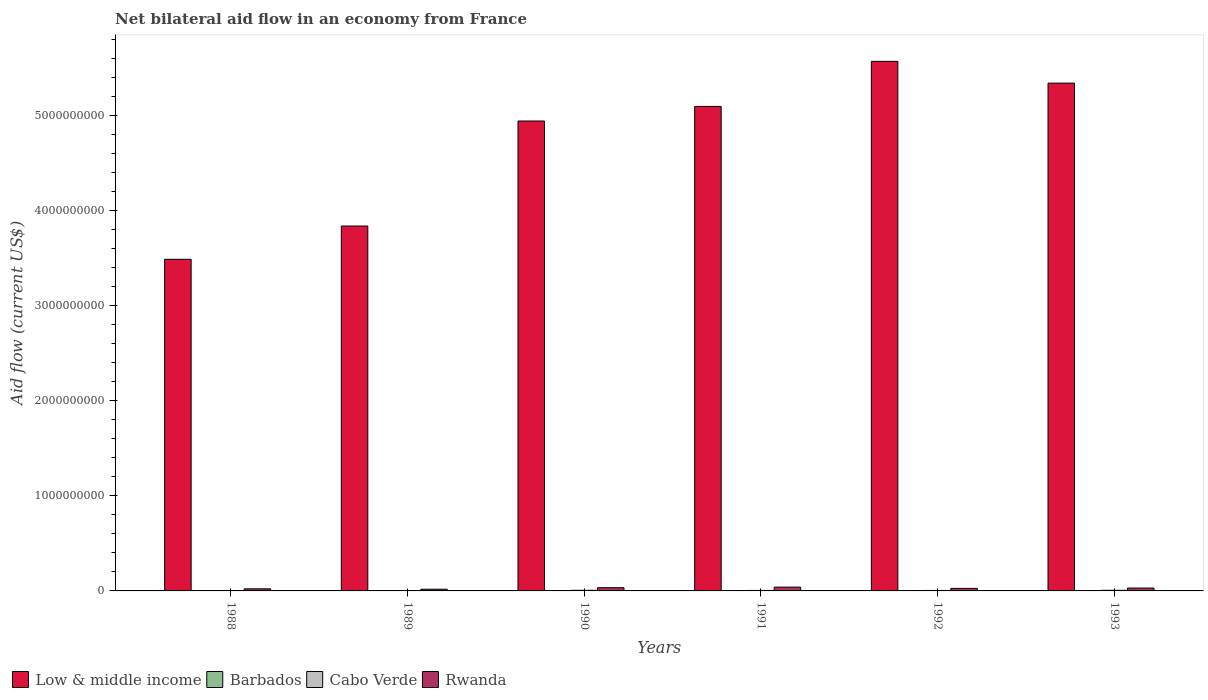How many groups of bars are there?
Make the answer very short. 6. Are the number of bars per tick equal to the number of legend labels?
Your answer should be very brief. Yes. How many bars are there on the 4th tick from the left?
Provide a short and direct response. 4. What is the label of the 6th group of bars from the left?
Offer a very short reply. 1993. In how many cases, is the number of bars for a given year not equal to the number of legend labels?
Keep it short and to the point. 0. What is the net bilateral aid flow in Rwanda in 1991?
Offer a terse response. 3.99e+07. Across all years, what is the maximum net bilateral aid flow in Barbados?
Your response must be concise. 10000. In which year was the net bilateral aid flow in Cabo Verde minimum?
Give a very brief answer. 1988. What is the total net bilateral aid flow in Low & middle income in the graph?
Your answer should be compact. 2.83e+1. What is the difference between the net bilateral aid flow in Low & middle income in 1991 and that in 1993?
Your answer should be compact. -2.45e+08. What is the difference between the net bilateral aid flow in Low & middle income in 1992 and the net bilateral aid flow in Rwanda in 1991?
Keep it short and to the point. 5.53e+09. What is the average net bilateral aid flow in Cabo Verde per year?
Keep it short and to the point. 5.15e+06. In the year 1991, what is the difference between the net bilateral aid flow in Barbados and net bilateral aid flow in Cabo Verde?
Your answer should be compact. -5.06e+06. In how many years, is the net bilateral aid flow in Barbados greater than 800000000 US$?
Keep it short and to the point. 0. What is the ratio of the net bilateral aid flow in Cabo Verde in 1992 to that in 1993?
Keep it short and to the point. 0.75. Is the net bilateral aid flow in Barbados in 1989 less than that in 1993?
Provide a succinct answer. No. What is the difference between the highest and the second highest net bilateral aid flow in Low & middle income?
Ensure brevity in your answer.  2.29e+08. What is the difference between the highest and the lowest net bilateral aid flow in Cabo Verde?
Offer a terse response. 2.54e+06. In how many years, is the net bilateral aid flow in Cabo Verde greater than the average net bilateral aid flow in Cabo Verde taken over all years?
Provide a short and direct response. 2. What does the 4th bar from the left in 1989 represents?
Your answer should be compact. Rwanda. What does the 2nd bar from the right in 1990 represents?
Your answer should be compact. Cabo Verde. How many bars are there?
Provide a short and direct response. 24. Are all the bars in the graph horizontal?
Your answer should be compact. No. How many years are there in the graph?
Offer a very short reply. 6. Does the graph contain any zero values?
Your answer should be compact. No. Does the graph contain grids?
Your answer should be very brief. No. Where does the legend appear in the graph?
Your answer should be very brief. Bottom left. How many legend labels are there?
Ensure brevity in your answer.  4. What is the title of the graph?
Provide a short and direct response. Net bilateral aid flow in an economy from France. Does "Nicaragua" appear as one of the legend labels in the graph?
Make the answer very short. No. What is the label or title of the X-axis?
Your response must be concise. Years. What is the label or title of the Y-axis?
Offer a terse response. Aid flow (current US$). What is the Aid flow (current US$) of Low & middle income in 1988?
Offer a terse response. 3.49e+09. What is the Aid flow (current US$) in Barbados in 1988?
Your answer should be very brief. 10000. What is the Aid flow (current US$) in Cabo Verde in 1988?
Ensure brevity in your answer.  3.98e+06. What is the Aid flow (current US$) in Rwanda in 1988?
Make the answer very short. 2.21e+07. What is the Aid flow (current US$) of Low & middle income in 1989?
Keep it short and to the point. 3.83e+09. What is the Aid flow (current US$) in Barbados in 1989?
Make the answer very short. 10000. What is the Aid flow (current US$) of Cabo Verde in 1989?
Provide a succinct answer. 4.01e+06. What is the Aid flow (current US$) of Rwanda in 1989?
Make the answer very short. 1.78e+07. What is the Aid flow (current US$) in Low & middle income in 1990?
Your answer should be very brief. 4.94e+09. What is the Aid flow (current US$) in Cabo Verde in 1990?
Give a very brief answer. 6.44e+06. What is the Aid flow (current US$) of Rwanda in 1990?
Provide a succinct answer. 3.39e+07. What is the Aid flow (current US$) of Low & middle income in 1991?
Your answer should be compact. 5.09e+09. What is the Aid flow (current US$) of Barbados in 1991?
Give a very brief answer. 10000. What is the Aid flow (current US$) in Cabo Verde in 1991?
Ensure brevity in your answer.  5.07e+06. What is the Aid flow (current US$) in Rwanda in 1991?
Provide a succinct answer. 3.99e+07. What is the Aid flow (current US$) of Low & middle income in 1992?
Your answer should be very brief. 5.57e+09. What is the Aid flow (current US$) of Cabo Verde in 1992?
Make the answer very short. 4.87e+06. What is the Aid flow (current US$) of Rwanda in 1992?
Your response must be concise. 2.67e+07. What is the Aid flow (current US$) in Low & middle income in 1993?
Your answer should be compact. 5.34e+09. What is the Aid flow (current US$) of Cabo Verde in 1993?
Offer a very short reply. 6.52e+06. What is the Aid flow (current US$) in Rwanda in 1993?
Provide a short and direct response. 3.03e+07. Across all years, what is the maximum Aid flow (current US$) of Low & middle income?
Provide a short and direct response. 5.57e+09. Across all years, what is the maximum Aid flow (current US$) of Barbados?
Make the answer very short. 10000. Across all years, what is the maximum Aid flow (current US$) of Cabo Verde?
Give a very brief answer. 6.52e+06. Across all years, what is the maximum Aid flow (current US$) in Rwanda?
Offer a very short reply. 3.99e+07. Across all years, what is the minimum Aid flow (current US$) in Low & middle income?
Offer a very short reply. 3.49e+09. Across all years, what is the minimum Aid flow (current US$) of Cabo Verde?
Your answer should be very brief. 3.98e+06. Across all years, what is the minimum Aid flow (current US$) of Rwanda?
Ensure brevity in your answer.  1.78e+07. What is the total Aid flow (current US$) of Low & middle income in the graph?
Make the answer very short. 2.83e+1. What is the total Aid flow (current US$) of Barbados in the graph?
Your answer should be compact. 6.00e+04. What is the total Aid flow (current US$) in Cabo Verde in the graph?
Make the answer very short. 3.09e+07. What is the total Aid flow (current US$) in Rwanda in the graph?
Ensure brevity in your answer.  1.71e+08. What is the difference between the Aid flow (current US$) in Low & middle income in 1988 and that in 1989?
Keep it short and to the point. -3.50e+08. What is the difference between the Aid flow (current US$) of Rwanda in 1988 and that in 1989?
Provide a short and direct response. 4.28e+06. What is the difference between the Aid flow (current US$) in Low & middle income in 1988 and that in 1990?
Ensure brevity in your answer.  -1.45e+09. What is the difference between the Aid flow (current US$) of Cabo Verde in 1988 and that in 1990?
Make the answer very short. -2.46e+06. What is the difference between the Aid flow (current US$) in Rwanda in 1988 and that in 1990?
Ensure brevity in your answer.  -1.18e+07. What is the difference between the Aid flow (current US$) in Low & middle income in 1988 and that in 1991?
Offer a terse response. -1.61e+09. What is the difference between the Aid flow (current US$) of Cabo Verde in 1988 and that in 1991?
Offer a terse response. -1.09e+06. What is the difference between the Aid flow (current US$) in Rwanda in 1988 and that in 1991?
Your answer should be very brief. -1.78e+07. What is the difference between the Aid flow (current US$) in Low & middle income in 1988 and that in 1992?
Offer a very short reply. -2.08e+09. What is the difference between the Aid flow (current US$) in Cabo Verde in 1988 and that in 1992?
Offer a terse response. -8.90e+05. What is the difference between the Aid flow (current US$) of Rwanda in 1988 and that in 1992?
Your answer should be compact. -4.63e+06. What is the difference between the Aid flow (current US$) in Low & middle income in 1988 and that in 1993?
Keep it short and to the point. -1.85e+09. What is the difference between the Aid flow (current US$) of Cabo Verde in 1988 and that in 1993?
Offer a terse response. -2.54e+06. What is the difference between the Aid flow (current US$) in Rwanda in 1988 and that in 1993?
Your response must be concise. -8.25e+06. What is the difference between the Aid flow (current US$) in Low & middle income in 1989 and that in 1990?
Keep it short and to the point. -1.10e+09. What is the difference between the Aid flow (current US$) of Cabo Verde in 1989 and that in 1990?
Make the answer very short. -2.43e+06. What is the difference between the Aid flow (current US$) in Rwanda in 1989 and that in 1990?
Offer a very short reply. -1.61e+07. What is the difference between the Aid flow (current US$) of Low & middle income in 1989 and that in 1991?
Your answer should be very brief. -1.26e+09. What is the difference between the Aid flow (current US$) in Barbados in 1989 and that in 1991?
Give a very brief answer. 0. What is the difference between the Aid flow (current US$) of Cabo Verde in 1989 and that in 1991?
Your answer should be compact. -1.06e+06. What is the difference between the Aid flow (current US$) in Rwanda in 1989 and that in 1991?
Offer a very short reply. -2.21e+07. What is the difference between the Aid flow (current US$) of Low & middle income in 1989 and that in 1992?
Offer a very short reply. -1.73e+09. What is the difference between the Aid flow (current US$) of Barbados in 1989 and that in 1992?
Your answer should be compact. 0. What is the difference between the Aid flow (current US$) of Cabo Verde in 1989 and that in 1992?
Your response must be concise. -8.60e+05. What is the difference between the Aid flow (current US$) in Rwanda in 1989 and that in 1992?
Your answer should be very brief. -8.91e+06. What is the difference between the Aid flow (current US$) of Low & middle income in 1989 and that in 1993?
Keep it short and to the point. -1.50e+09. What is the difference between the Aid flow (current US$) in Cabo Verde in 1989 and that in 1993?
Provide a succinct answer. -2.51e+06. What is the difference between the Aid flow (current US$) of Rwanda in 1989 and that in 1993?
Make the answer very short. -1.25e+07. What is the difference between the Aid flow (current US$) of Low & middle income in 1990 and that in 1991?
Your answer should be compact. -1.53e+08. What is the difference between the Aid flow (current US$) of Cabo Verde in 1990 and that in 1991?
Your answer should be compact. 1.37e+06. What is the difference between the Aid flow (current US$) of Rwanda in 1990 and that in 1991?
Provide a succinct answer. -6.00e+06. What is the difference between the Aid flow (current US$) in Low & middle income in 1990 and that in 1992?
Provide a short and direct response. -6.27e+08. What is the difference between the Aid flow (current US$) of Cabo Verde in 1990 and that in 1992?
Make the answer very short. 1.57e+06. What is the difference between the Aid flow (current US$) in Rwanda in 1990 and that in 1992?
Provide a succinct answer. 7.22e+06. What is the difference between the Aid flow (current US$) of Low & middle income in 1990 and that in 1993?
Your answer should be very brief. -3.98e+08. What is the difference between the Aid flow (current US$) in Barbados in 1990 and that in 1993?
Provide a succinct answer. 0. What is the difference between the Aid flow (current US$) of Cabo Verde in 1990 and that in 1993?
Your answer should be compact. -8.00e+04. What is the difference between the Aid flow (current US$) of Rwanda in 1990 and that in 1993?
Your answer should be very brief. 3.60e+06. What is the difference between the Aid flow (current US$) in Low & middle income in 1991 and that in 1992?
Offer a terse response. -4.74e+08. What is the difference between the Aid flow (current US$) in Rwanda in 1991 and that in 1992?
Your response must be concise. 1.32e+07. What is the difference between the Aid flow (current US$) of Low & middle income in 1991 and that in 1993?
Provide a short and direct response. -2.45e+08. What is the difference between the Aid flow (current US$) of Barbados in 1991 and that in 1993?
Provide a succinct answer. 0. What is the difference between the Aid flow (current US$) in Cabo Verde in 1991 and that in 1993?
Provide a succinct answer. -1.45e+06. What is the difference between the Aid flow (current US$) in Rwanda in 1991 and that in 1993?
Your answer should be very brief. 9.60e+06. What is the difference between the Aid flow (current US$) of Low & middle income in 1992 and that in 1993?
Keep it short and to the point. 2.29e+08. What is the difference between the Aid flow (current US$) in Barbados in 1992 and that in 1993?
Your answer should be compact. 0. What is the difference between the Aid flow (current US$) of Cabo Verde in 1992 and that in 1993?
Offer a terse response. -1.65e+06. What is the difference between the Aid flow (current US$) in Rwanda in 1992 and that in 1993?
Keep it short and to the point. -3.62e+06. What is the difference between the Aid flow (current US$) in Low & middle income in 1988 and the Aid flow (current US$) in Barbados in 1989?
Your response must be concise. 3.49e+09. What is the difference between the Aid flow (current US$) of Low & middle income in 1988 and the Aid flow (current US$) of Cabo Verde in 1989?
Provide a short and direct response. 3.48e+09. What is the difference between the Aid flow (current US$) in Low & middle income in 1988 and the Aid flow (current US$) in Rwanda in 1989?
Make the answer very short. 3.47e+09. What is the difference between the Aid flow (current US$) of Barbados in 1988 and the Aid flow (current US$) of Cabo Verde in 1989?
Provide a short and direct response. -4.00e+06. What is the difference between the Aid flow (current US$) in Barbados in 1988 and the Aid flow (current US$) in Rwanda in 1989?
Offer a very short reply. -1.78e+07. What is the difference between the Aid flow (current US$) in Cabo Verde in 1988 and the Aid flow (current US$) in Rwanda in 1989?
Your response must be concise. -1.38e+07. What is the difference between the Aid flow (current US$) in Low & middle income in 1988 and the Aid flow (current US$) in Barbados in 1990?
Give a very brief answer. 3.49e+09. What is the difference between the Aid flow (current US$) in Low & middle income in 1988 and the Aid flow (current US$) in Cabo Verde in 1990?
Your answer should be very brief. 3.48e+09. What is the difference between the Aid flow (current US$) in Low & middle income in 1988 and the Aid flow (current US$) in Rwanda in 1990?
Offer a terse response. 3.45e+09. What is the difference between the Aid flow (current US$) of Barbados in 1988 and the Aid flow (current US$) of Cabo Verde in 1990?
Provide a succinct answer. -6.43e+06. What is the difference between the Aid flow (current US$) in Barbados in 1988 and the Aid flow (current US$) in Rwanda in 1990?
Offer a very short reply. -3.39e+07. What is the difference between the Aid flow (current US$) of Cabo Verde in 1988 and the Aid flow (current US$) of Rwanda in 1990?
Provide a succinct answer. -2.99e+07. What is the difference between the Aid flow (current US$) of Low & middle income in 1988 and the Aid flow (current US$) of Barbados in 1991?
Provide a succinct answer. 3.49e+09. What is the difference between the Aid flow (current US$) of Low & middle income in 1988 and the Aid flow (current US$) of Cabo Verde in 1991?
Your response must be concise. 3.48e+09. What is the difference between the Aid flow (current US$) in Low & middle income in 1988 and the Aid flow (current US$) in Rwanda in 1991?
Your response must be concise. 3.45e+09. What is the difference between the Aid flow (current US$) in Barbados in 1988 and the Aid flow (current US$) in Cabo Verde in 1991?
Offer a terse response. -5.06e+06. What is the difference between the Aid flow (current US$) in Barbados in 1988 and the Aid flow (current US$) in Rwanda in 1991?
Give a very brief answer. -3.99e+07. What is the difference between the Aid flow (current US$) of Cabo Verde in 1988 and the Aid flow (current US$) of Rwanda in 1991?
Offer a terse response. -3.59e+07. What is the difference between the Aid flow (current US$) of Low & middle income in 1988 and the Aid flow (current US$) of Barbados in 1992?
Keep it short and to the point. 3.49e+09. What is the difference between the Aid flow (current US$) in Low & middle income in 1988 and the Aid flow (current US$) in Cabo Verde in 1992?
Keep it short and to the point. 3.48e+09. What is the difference between the Aid flow (current US$) in Low & middle income in 1988 and the Aid flow (current US$) in Rwanda in 1992?
Keep it short and to the point. 3.46e+09. What is the difference between the Aid flow (current US$) of Barbados in 1988 and the Aid flow (current US$) of Cabo Verde in 1992?
Your answer should be very brief. -4.86e+06. What is the difference between the Aid flow (current US$) in Barbados in 1988 and the Aid flow (current US$) in Rwanda in 1992?
Make the answer very short. -2.67e+07. What is the difference between the Aid flow (current US$) of Cabo Verde in 1988 and the Aid flow (current US$) of Rwanda in 1992?
Offer a very short reply. -2.27e+07. What is the difference between the Aid flow (current US$) in Low & middle income in 1988 and the Aid flow (current US$) in Barbados in 1993?
Offer a terse response. 3.49e+09. What is the difference between the Aid flow (current US$) of Low & middle income in 1988 and the Aid flow (current US$) of Cabo Verde in 1993?
Provide a short and direct response. 3.48e+09. What is the difference between the Aid flow (current US$) of Low & middle income in 1988 and the Aid flow (current US$) of Rwanda in 1993?
Your answer should be compact. 3.45e+09. What is the difference between the Aid flow (current US$) of Barbados in 1988 and the Aid flow (current US$) of Cabo Verde in 1993?
Your response must be concise. -6.51e+06. What is the difference between the Aid flow (current US$) of Barbados in 1988 and the Aid flow (current US$) of Rwanda in 1993?
Provide a succinct answer. -3.03e+07. What is the difference between the Aid flow (current US$) in Cabo Verde in 1988 and the Aid flow (current US$) in Rwanda in 1993?
Give a very brief answer. -2.63e+07. What is the difference between the Aid flow (current US$) of Low & middle income in 1989 and the Aid flow (current US$) of Barbados in 1990?
Your response must be concise. 3.83e+09. What is the difference between the Aid flow (current US$) in Low & middle income in 1989 and the Aid flow (current US$) in Cabo Verde in 1990?
Provide a succinct answer. 3.83e+09. What is the difference between the Aid flow (current US$) of Low & middle income in 1989 and the Aid flow (current US$) of Rwanda in 1990?
Make the answer very short. 3.80e+09. What is the difference between the Aid flow (current US$) of Barbados in 1989 and the Aid flow (current US$) of Cabo Verde in 1990?
Offer a terse response. -6.43e+06. What is the difference between the Aid flow (current US$) in Barbados in 1989 and the Aid flow (current US$) in Rwanda in 1990?
Keep it short and to the point. -3.39e+07. What is the difference between the Aid flow (current US$) of Cabo Verde in 1989 and the Aid flow (current US$) of Rwanda in 1990?
Give a very brief answer. -2.99e+07. What is the difference between the Aid flow (current US$) of Low & middle income in 1989 and the Aid flow (current US$) of Barbados in 1991?
Your answer should be very brief. 3.83e+09. What is the difference between the Aid flow (current US$) in Low & middle income in 1989 and the Aid flow (current US$) in Cabo Verde in 1991?
Your response must be concise. 3.83e+09. What is the difference between the Aid flow (current US$) in Low & middle income in 1989 and the Aid flow (current US$) in Rwanda in 1991?
Keep it short and to the point. 3.79e+09. What is the difference between the Aid flow (current US$) of Barbados in 1989 and the Aid flow (current US$) of Cabo Verde in 1991?
Offer a very short reply. -5.06e+06. What is the difference between the Aid flow (current US$) of Barbados in 1989 and the Aid flow (current US$) of Rwanda in 1991?
Offer a terse response. -3.99e+07. What is the difference between the Aid flow (current US$) of Cabo Verde in 1989 and the Aid flow (current US$) of Rwanda in 1991?
Keep it short and to the point. -3.59e+07. What is the difference between the Aid flow (current US$) of Low & middle income in 1989 and the Aid flow (current US$) of Barbados in 1992?
Provide a short and direct response. 3.83e+09. What is the difference between the Aid flow (current US$) in Low & middle income in 1989 and the Aid flow (current US$) in Cabo Verde in 1992?
Offer a terse response. 3.83e+09. What is the difference between the Aid flow (current US$) in Low & middle income in 1989 and the Aid flow (current US$) in Rwanda in 1992?
Make the answer very short. 3.81e+09. What is the difference between the Aid flow (current US$) in Barbados in 1989 and the Aid flow (current US$) in Cabo Verde in 1992?
Ensure brevity in your answer.  -4.86e+06. What is the difference between the Aid flow (current US$) in Barbados in 1989 and the Aid flow (current US$) in Rwanda in 1992?
Offer a very short reply. -2.67e+07. What is the difference between the Aid flow (current US$) in Cabo Verde in 1989 and the Aid flow (current US$) in Rwanda in 1992?
Offer a terse response. -2.27e+07. What is the difference between the Aid flow (current US$) in Low & middle income in 1989 and the Aid flow (current US$) in Barbados in 1993?
Your answer should be very brief. 3.83e+09. What is the difference between the Aid flow (current US$) in Low & middle income in 1989 and the Aid flow (current US$) in Cabo Verde in 1993?
Make the answer very short. 3.83e+09. What is the difference between the Aid flow (current US$) of Low & middle income in 1989 and the Aid flow (current US$) of Rwanda in 1993?
Make the answer very short. 3.80e+09. What is the difference between the Aid flow (current US$) of Barbados in 1989 and the Aid flow (current US$) of Cabo Verde in 1993?
Make the answer very short. -6.51e+06. What is the difference between the Aid flow (current US$) in Barbados in 1989 and the Aid flow (current US$) in Rwanda in 1993?
Give a very brief answer. -3.03e+07. What is the difference between the Aid flow (current US$) in Cabo Verde in 1989 and the Aid flow (current US$) in Rwanda in 1993?
Keep it short and to the point. -2.63e+07. What is the difference between the Aid flow (current US$) of Low & middle income in 1990 and the Aid flow (current US$) of Barbados in 1991?
Offer a very short reply. 4.94e+09. What is the difference between the Aid flow (current US$) in Low & middle income in 1990 and the Aid flow (current US$) in Cabo Verde in 1991?
Keep it short and to the point. 4.93e+09. What is the difference between the Aid flow (current US$) in Low & middle income in 1990 and the Aid flow (current US$) in Rwanda in 1991?
Your answer should be compact. 4.90e+09. What is the difference between the Aid flow (current US$) of Barbados in 1990 and the Aid flow (current US$) of Cabo Verde in 1991?
Provide a succinct answer. -5.06e+06. What is the difference between the Aid flow (current US$) of Barbados in 1990 and the Aid flow (current US$) of Rwanda in 1991?
Your answer should be compact. -3.99e+07. What is the difference between the Aid flow (current US$) in Cabo Verde in 1990 and the Aid flow (current US$) in Rwanda in 1991?
Provide a short and direct response. -3.35e+07. What is the difference between the Aid flow (current US$) in Low & middle income in 1990 and the Aid flow (current US$) in Barbados in 1992?
Your response must be concise. 4.94e+09. What is the difference between the Aid flow (current US$) of Low & middle income in 1990 and the Aid flow (current US$) of Cabo Verde in 1992?
Your response must be concise. 4.93e+09. What is the difference between the Aid flow (current US$) of Low & middle income in 1990 and the Aid flow (current US$) of Rwanda in 1992?
Provide a succinct answer. 4.91e+09. What is the difference between the Aid flow (current US$) of Barbados in 1990 and the Aid flow (current US$) of Cabo Verde in 1992?
Your answer should be very brief. -4.86e+06. What is the difference between the Aid flow (current US$) of Barbados in 1990 and the Aid flow (current US$) of Rwanda in 1992?
Offer a very short reply. -2.67e+07. What is the difference between the Aid flow (current US$) of Cabo Verde in 1990 and the Aid flow (current US$) of Rwanda in 1992?
Keep it short and to the point. -2.03e+07. What is the difference between the Aid flow (current US$) of Low & middle income in 1990 and the Aid flow (current US$) of Barbados in 1993?
Keep it short and to the point. 4.94e+09. What is the difference between the Aid flow (current US$) in Low & middle income in 1990 and the Aid flow (current US$) in Cabo Verde in 1993?
Make the answer very short. 4.93e+09. What is the difference between the Aid flow (current US$) of Low & middle income in 1990 and the Aid flow (current US$) of Rwanda in 1993?
Provide a succinct answer. 4.91e+09. What is the difference between the Aid flow (current US$) of Barbados in 1990 and the Aid flow (current US$) of Cabo Verde in 1993?
Offer a very short reply. -6.51e+06. What is the difference between the Aid flow (current US$) in Barbados in 1990 and the Aid flow (current US$) in Rwanda in 1993?
Provide a succinct answer. -3.03e+07. What is the difference between the Aid flow (current US$) of Cabo Verde in 1990 and the Aid flow (current US$) of Rwanda in 1993?
Ensure brevity in your answer.  -2.39e+07. What is the difference between the Aid flow (current US$) of Low & middle income in 1991 and the Aid flow (current US$) of Barbados in 1992?
Offer a very short reply. 5.09e+09. What is the difference between the Aid flow (current US$) of Low & middle income in 1991 and the Aid flow (current US$) of Cabo Verde in 1992?
Offer a very short reply. 5.09e+09. What is the difference between the Aid flow (current US$) in Low & middle income in 1991 and the Aid flow (current US$) in Rwanda in 1992?
Ensure brevity in your answer.  5.07e+09. What is the difference between the Aid flow (current US$) of Barbados in 1991 and the Aid flow (current US$) of Cabo Verde in 1992?
Make the answer very short. -4.86e+06. What is the difference between the Aid flow (current US$) in Barbados in 1991 and the Aid flow (current US$) in Rwanda in 1992?
Provide a succinct answer. -2.67e+07. What is the difference between the Aid flow (current US$) of Cabo Verde in 1991 and the Aid flow (current US$) of Rwanda in 1992?
Make the answer very short. -2.16e+07. What is the difference between the Aid flow (current US$) in Low & middle income in 1991 and the Aid flow (current US$) in Barbados in 1993?
Your answer should be compact. 5.09e+09. What is the difference between the Aid flow (current US$) of Low & middle income in 1991 and the Aid flow (current US$) of Cabo Verde in 1993?
Keep it short and to the point. 5.09e+09. What is the difference between the Aid flow (current US$) in Low & middle income in 1991 and the Aid flow (current US$) in Rwanda in 1993?
Your answer should be very brief. 5.06e+09. What is the difference between the Aid flow (current US$) in Barbados in 1991 and the Aid flow (current US$) in Cabo Verde in 1993?
Give a very brief answer. -6.51e+06. What is the difference between the Aid flow (current US$) in Barbados in 1991 and the Aid flow (current US$) in Rwanda in 1993?
Give a very brief answer. -3.03e+07. What is the difference between the Aid flow (current US$) of Cabo Verde in 1991 and the Aid flow (current US$) of Rwanda in 1993?
Provide a succinct answer. -2.52e+07. What is the difference between the Aid flow (current US$) of Low & middle income in 1992 and the Aid flow (current US$) of Barbados in 1993?
Ensure brevity in your answer.  5.57e+09. What is the difference between the Aid flow (current US$) in Low & middle income in 1992 and the Aid flow (current US$) in Cabo Verde in 1993?
Provide a short and direct response. 5.56e+09. What is the difference between the Aid flow (current US$) of Low & middle income in 1992 and the Aid flow (current US$) of Rwanda in 1993?
Make the answer very short. 5.54e+09. What is the difference between the Aid flow (current US$) of Barbados in 1992 and the Aid flow (current US$) of Cabo Verde in 1993?
Provide a succinct answer. -6.51e+06. What is the difference between the Aid flow (current US$) in Barbados in 1992 and the Aid flow (current US$) in Rwanda in 1993?
Keep it short and to the point. -3.03e+07. What is the difference between the Aid flow (current US$) in Cabo Verde in 1992 and the Aid flow (current US$) in Rwanda in 1993?
Offer a very short reply. -2.54e+07. What is the average Aid flow (current US$) of Low & middle income per year?
Keep it short and to the point. 4.71e+09. What is the average Aid flow (current US$) in Cabo Verde per year?
Your response must be concise. 5.15e+06. What is the average Aid flow (current US$) of Rwanda per year?
Your response must be concise. 2.85e+07. In the year 1988, what is the difference between the Aid flow (current US$) of Low & middle income and Aid flow (current US$) of Barbados?
Your answer should be compact. 3.49e+09. In the year 1988, what is the difference between the Aid flow (current US$) of Low & middle income and Aid flow (current US$) of Cabo Verde?
Your answer should be compact. 3.48e+09. In the year 1988, what is the difference between the Aid flow (current US$) of Low & middle income and Aid flow (current US$) of Rwanda?
Ensure brevity in your answer.  3.46e+09. In the year 1988, what is the difference between the Aid flow (current US$) of Barbados and Aid flow (current US$) of Cabo Verde?
Provide a short and direct response. -3.97e+06. In the year 1988, what is the difference between the Aid flow (current US$) in Barbados and Aid flow (current US$) in Rwanda?
Your answer should be very brief. -2.21e+07. In the year 1988, what is the difference between the Aid flow (current US$) in Cabo Verde and Aid flow (current US$) in Rwanda?
Provide a short and direct response. -1.81e+07. In the year 1989, what is the difference between the Aid flow (current US$) of Low & middle income and Aid flow (current US$) of Barbados?
Make the answer very short. 3.83e+09. In the year 1989, what is the difference between the Aid flow (current US$) of Low & middle income and Aid flow (current US$) of Cabo Verde?
Provide a short and direct response. 3.83e+09. In the year 1989, what is the difference between the Aid flow (current US$) of Low & middle income and Aid flow (current US$) of Rwanda?
Offer a terse response. 3.82e+09. In the year 1989, what is the difference between the Aid flow (current US$) of Barbados and Aid flow (current US$) of Rwanda?
Provide a succinct answer. -1.78e+07. In the year 1989, what is the difference between the Aid flow (current US$) of Cabo Verde and Aid flow (current US$) of Rwanda?
Ensure brevity in your answer.  -1.38e+07. In the year 1990, what is the difference between the Aid flow (current US$) in Low & middle income and Aid flow (current US$) in Barbados?
Your response must be concise. 4.94e+09. In the year 1990, what is the difference between the Aid flow (current US$) in Low & middle income and Aid flow (current US$) in Cabo Verde?
Make the answer very short. 4.93e+09. In the year 1990, what is the difference between the Aid flow (current US$) in Low & middle income and Aid flow (current US$) in Rwanda?
Give a very brief answer. 4.90e+09. In the year 1990, what is the difference between the Aid flow (current US$) in Barbados and Aid flow (current US$) in Cabo Verde?
Provide a succinct answer. -6.43e+06. In the year 1990, what is the difference between the Aid flow (current US$) of Barbados and Aid flow (current US$) of Rwanda?
Provide a short and direct response. -3.39e+07. In the year 1990, what is the difference between the Aid flow (current US$) of Cabo Verde and Aid flow (current US$) of Rwanda?
Offer a terse response. -2.75e+07. In the year 1991, what is the difference between the Aid flow (current US$) in Low & middle income and Aid flow (current US$) in Barbados?
Offer a terse response. 5.09e+09. In the year 1991, what is the difference between the Aid flow (current US$) in Low & middle income and Aid flow (current US$) in Cabo Verde?
Offer a terse response. 5.09e+09. In the year 1991, what is the difference between the Aid flow (current US$) of Low & middle income and Aid flow (current US$) of Rwanda?
Offer a very short reply. 5.05e+09. In the year 1991, what is the difference between the Aid flow (current US$) of Barbados and Aid flow (current US$) of Cabo Verde?
Ensure brevity in your answer.  -5.06e+06. In the year 1991, what is the difference between the Aid flow (current US$) of Barbados and Aid flow (current US$) of Rwanda?
Provide a short and direct response. -3.99e+07. In the year 1991, what is the difference between the Aid flow (current US$) of Cabo Verde and Aid flow (current US$) of Rwanda?
Offer a very short reply. -3.48e+07. In the year 1992, what is the difference between the Aid flow (current US$) in Low & middle income and Aid flow (current US$) in Barbados?
Provide a succinct answer. 5.57e+09. In the year 1992, what is the difference between the Aid flow (current US$) in Low & middle income and Aid flow (current US$) in Cabo Verde?
Give a very brief answer. 5.56e+09. In the year 1992, what is the difference between the Aid flow (current US$) of Low & middle income and Aid flow (current US$) of Rwanda?
Your answer should be compact. 5.54e+09. In the year 1992, what is the difference between the Aid flow (current US$) in Barbados and Aid flow (current US$) in Cabo Verde?
Ensure brevity in your answer.  -4.86e+06. In the year 1992, what is the difference between the Aid flow (current US$) of Barbados and Aid flow (current US$) of Rwanda?
Provide a short and direct response. -2.67e+07. In the year 1992, what is the difference between the Aid flow (current US$) of Cabo Verde and Aid flow (current US$) of Rwanda?
Provide a short and direct response. -2.18e+07. In the year 1993, what is the difference between the Aid flow (current US$) of Low & middle income and Aid flow (current US$) of Barbados?
Offer a very short reply. 5.34e+09. In the year 1993, what is the difference between the Aid flow (current US$) of Low & middle income and Aid flow (current US$) of Cabo Verde?
Provide a short and direct response. 5.33e+09. In the year 1993, what is the difference between the Aid flow (current US$) of Low & middle income and Aid flow (current US$) of Rwanda?
Offer a terse response. 5.31e+09. In the year 1993, what is the difference between the Aid flow (current US$) in Barbados and Aid flow (current US$) in Cabo Verde?
Give a very brief answer. -6.51e+06. In the year 1993, what is the difference between the Aid flow (current US$) in Barbados and Aid flow (current US$) in Rwanda?
Ensure brevity in your answer.  -3.03e+07. In the year 1993, what is the difference between the Aid flow (current US$) of Cabo Verde and Aid flow (current US$) of Rwanda?
Keep it short and to the point. -2.38e+07. What is the ratio of the Aid flow (current US$) in Low & middle income in 1988 to that in 1989?
Your answer should be compact. 0.91. What is the ratio of the Aid flow (current US$) of Rwanda in 1988 to that in 1989?
Provide a succinct answer. 1.24. What is the ratio of the Aid flow (current US$) of Low & middle income in 1988 to that in 1990?
Provide a succinct answer. 0.71. What is the ratio of the Aid flow (current US$) of Barbados in 1988 to that in 1990?
Offer a very short reply. 1. What is the ratio of the Aid flow (current US$) in Cabo Verde in 1988 to that in 1990?
Your answer should be very brief. 0.62. What is the ratio of the Aid flow (current US$) of Rwanda in 1988 to that in 1990?
Your answer should be very brief. 0.65. What is the ratio of the Aid flow (current US$) of Low & middle income in 1988 to that in 1991?
Make the answer very short. 0.68. What is the ratio of the Aid flow (current US$) in Barbados in 1988 to that in 1991?
Give a very brief answer. 1. What is the ratio of the Aid flow (current US$) of Cabo Verde in 1988 to that in 1991?
Give a very brief answer. 0.79. What is the ratio of the Aid flow (current US$) in Rwanda in 1988 to that in 1991?
Your response must be concise. 0.55. What is the ratio of the Aid flow (current US$) in Low & middle income in 1988 to that in 1992?
Make the answer very short. 0.63. What is the ratio of the Aid flow (current US$) in Barbados in 1988 to that in 1992?
Keep it short and to the point. 1. What is the ratio of the Aid flow (current US$) in Cabo Verde in 1988 to that in 1992?
Ensure brevity in your answer.  0.82. What is the ratio of the Aid flow (current US$) in Rwanda in 1988 to that in 1992?
Your answer should be very brief. 0.83. What is the ratio of the Aid flow (current US$) of Low & middle income in 1988 to that in 1993?
Give a very brief answer. 0.65. What is the ratio of the Aid flow (current US$) of Barbados in 1988 to that in 1993?
Provide a short and direct response. 1. What is the ratio of the Aid flow (current US$) of Cabo Verde in 1988 to that in 1993?
Your answer should be very brief. 0.61. What is the ratio of the Aid flow (current US$) of Rwanda in 1988 to that in 1993?
Give a very brief answer. 0.73. What is the ratio of the Aid flow (current US$) in Low & middle income in 1989 to that in 1990?
Make the answer very short. 0.78. What is the ratio of the Aid flow (current US$) in Cabo Verde in 1989 to that in 1990?
Make the answer very short. 0.62. What is the ratio of the Aid flow (current US$) in Rwanda in 1989 to that in 1990?
Ensure brevity in your answer.  0.52. What is the ratio of the Aid flow (current US$) in Low & middle income in 1989 to that in 1991?
Your answer should be compact. 0.75. What is the ratio of the Aid flow (current US$) of Cabo Verde in 1989 to that in 1991?
Provide a short and direct response. 0.79. What is the ratio of the Aid flow (current US$) in Rwanda in 1989 to that in 1991?
Offer a very short reply. 0.45. What is the ratio of the Aid flow (current US$) in Low & middle income in 1989 to that in 1992?
Give a very brief answer. 0.69. What is the ratio of the Aid flow (current US$) in Barbados in 1989 to that in 1992?
Offer a terse response. 1. What is the ratio of the Aid flow (current US$) of Cabo Verde in 1989 to that in 1992?
Give a very brief answer. 0.82. What is the ratio of the Aid flow (current US$) of Rwanda in 1989 to that in 1992?
Offer a terse response. 0.67. What is the ratio of the Aid flow (current US$) in Low & middle income in 1989 to that in 1993?
Your answer should be compact. 0.72. What is the ratio of the Aid flow (current US$) in Cabo Verde in 1989 to that in 1993?
Ensure brevity in your answer.  0.61. What is the ratio of the Aid flow (current US$) of Rwanda in 1989 to that in 1993?
Provide a short and direct response. 0.59. What is the ratio of the Aid flow (current US$) of Low & middle income in 1990 to that in 1991?
Offer a very short reply. 0.97. What is the ratio of the Aid flow (current US$) of Barbados in 1990 to that in 1991?
Offer a very short reply. 1. What is the ratio of the Aid flow (current US$) of Cabo Verde in 1990 to that in 1991?
Keep it short and to the point. 1.27. What is the ratio of the Aid flow (current US$) in Rwanda in 1990 to that in 1991?
Your response must be concise. 0.85. What is the ratio of the Aid flow (current US$) of Low & middle income in 1990 to that in 1992?
Keep it short and to the point. 0.89. What is the ratio of the Aid flow (current US$) of Barbados in 1990 to that in 1992?
Provide a short and direct response. 1. What is the ratio of the Aid flow (current US$) of Cabo Verde in 1990 to that in 1992?
Your response must be concise. 1.32. What is the ratio of the Aid flow (current US$) in Rwanda in 1990 to that in 1992?
Your answer should be compact. 1.27. What is the ratio of the Aid flow (current US$) in Low & middle income in 1990 to that in 1993?
Keep it short and to the point. 0.93. What is the ratio of the Aid flow (current US$) of Cabo Verde in 1990 to that in 1993?
Offer a terse response. 0.99. What is the ratio of the Aid flow (current US$) of Rwanda in 1990 to that in 1993?
Your response must be concise. 1.12. What is the ratio of the Aid flow (current US$) in Low & middle income in 1991 to that in 1992?
Provide a short and direct response. 0.91. What is the ratio of the Aid flow (current US$) in Cabo Verde in 1991 to that in 1992?
Your answer should be very brief. 1.04. What is the ratio of the Aid flow (current US$) in Rwanda in 1991 to that in 1992?
Provide a succinct answer. 1.5. What is the ratio of the Aid flow (current US$) in Low & middle income in 1991 to that in 1993?
Offer a very short reply. 0.95. What is the ratio of the Aid flow (current US$) of Barbados in 1991 to that in 1993?
Make the answer very short. 1. What is the ratio of the Aid flow (current US$) in Cabo Verde in 1991 to that in 1993?
Ensure brevity in your answer.  0.78. What is the ratio of the Aid flow (current US$) of Rwanda in 1991 to that in 1993?
Give a very brief answer. 1.32. What is the ratio of the Aid flow (current US$) of Low & middle income in 1992 to that in 1993?
Provide a succinct answer. 1.04. What is the ratio of the Aid flow (current US$) of Cabo Verde in 1992 to that in 1993?
Your answer should be compact. 0.75. What is the ratio of the Aid flow (current US$) of Rwanda in 1992 to that in 1993?
Provide a succinct answer. 0.88. What is the difference between the highest and the second highest Aid flow (current US$) in Low & middle income?
Your answer should be very brief. 2.29e+08. What is the difference between the highest and the second highest Aid flow (current US$) in Barbados?
Offer a very short reply. 0. What is the difference between the highest and the second highest Aid flow (current US$) in Cabo Verde?
Ensure brevity in your answer.  8.00e+04. What is the difference between the highest and the second highest Aid flow (current US$) in Rwanda?
Offer a very short reply. 6.00e+06. What is the difference between the highest and the lowest Aid flow (current US$) in Low & middle income?
Your response must be concise. 2.08e+09. What is the difference between the highest and the lowest Aid flow (current US$) in Cabo Verde?
Provide a succinct answer. 2.54e+06. What is the difference between the highest and the lowest Aid flow (current US$) of Rwanda?
Offer a terse response. 2.21e+07. 